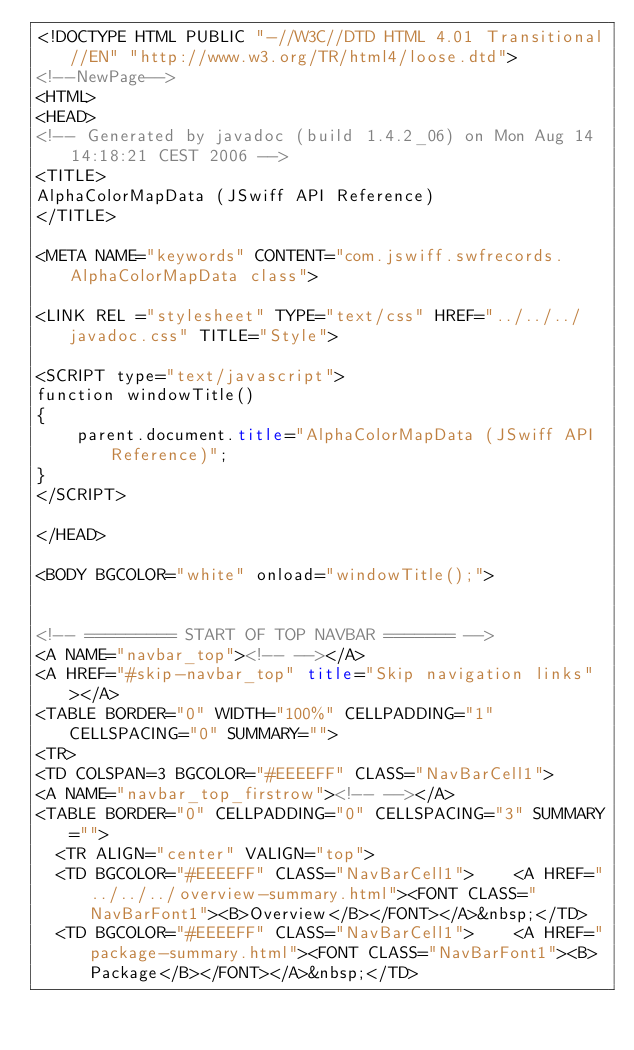<code> <loc_0><loc_0><loc_500><loc_500><_HTML_><!DOCTYPE HTML PUBLIC "-//W3C//DTD HTML 4.01 Transitional//EN" "http://www.w3.org/TR/html4/loose.dtd">
<!--NewPage-->
<HTML>
<HEAD>
<!-- Generated by javadoc (build 1.4.2_06) on Mon Aug 14 14:18:21 CEST 2006 -->
<TITLE>
AlphaColorMapData (JSwiff API Reference)
</TITLE>

<META NAME="keywords" CONTENT="com.jswiff.swfrecords.AlphaColorMapData class">

<LINK REL ="stylesheet" TYPE="text/css" HREF="../../../javadoc.css" TITLE="Style">

<SCRIPT type="text/javascript">
function windowTitle()
{
    parent.document.title="AlphaColorMapData (JSwiff API Reference)";
}
</SCRIPT>

</HEAD>

<BODY BGCOLOR="white" onload="windowTitle();">


<!-- ========= START OF TOP NAVBAR ======= -->
<A NAME="navbar_top"><!-- --></A>
<A HREF="#skip-navbar_top" title="Skip navigation links"></A>
<TABLE BORDER="0" WIDTH="100%" CELLPADDING="1" CELLSPACING="0" SUMMARY="">
<TR>
<TD COLSPAN=3 BGCOLOR="#EEEEFF" CLASS="NavBarCell1">
<A NAME="navbar_top_firstrow"><!-- --></A>
<TABLE BORDER="0" CELLPADDING="0" CELLSPACING="3" SUMMARY="">
  <TR ALIGN="center" VALIGN="top">
  <TD BGCOLOR="#EEEEFF" CLASS="NavBarCell1">    <A HREF="../../../overview-summary.html"><FONT CLASS="NavBarFont1"><B>Overview</B></FONT></A>&nbsp;</TD>
  <TD BGCOLOR="#EEEEFF" CLASS="NavBarCell1">    <A HREF="package-summary.html"><FONT CLASS="NavBarFont1"><B>Package</B></FONT></A>&nbsp;</TD></code> 